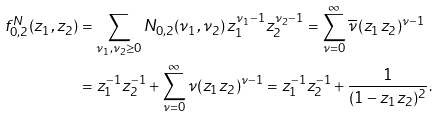Convert formula to latex. <formula><loc_0><loc_0><loc_500><loc_500>f _ { 0 , 2 } ^ { N } ( z _ { 1 } , z _ { 2 } ) & = \sum _ { \nu _ { 1 } , \nu _ { 2 } \geq 0 } N _ { 0 , 2 } ( \nu _ { 1 } , \nu _ { 2 } ) \, z _ { 1 } ^ { \nu _ { 1 } - 1 } z _ { 2 } ^ { \nu _ { 2 } - 1 } = \sum _ { \nu = 0 } ^ { \infty } \overline { \nu } \, ( z _ { 1 } z _ { 2 } ) ^ { \nu - 1 } \\ & = z _ { 1 } ^ { - 1 } z _ { 2 } ^ { - 1 } + \sum _ { \nu = 0 } ^ { \infty } \nu ( z _ { 1 } z _ { 2 } ) ^ { \nu - 1 } = z _ { 1 } ^ { - 1 } z _ { 2 } ^ { - 1 } + \frac { 1 } { ( 1 - z _ { 1 } z _ { 2 } ) ^ { 2 } } .</formula> 